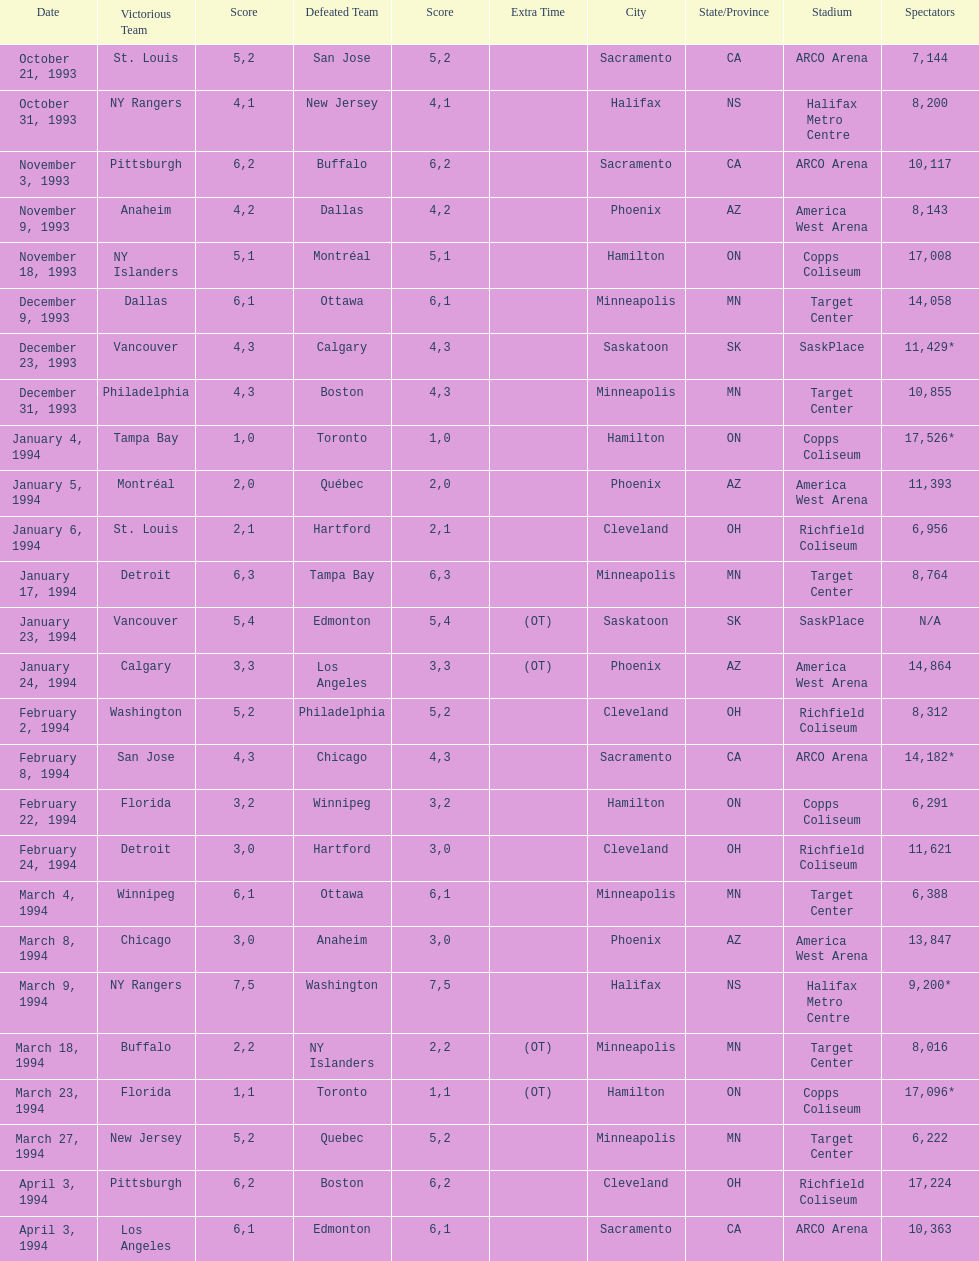How many games have been held in minneapolis? 6. 